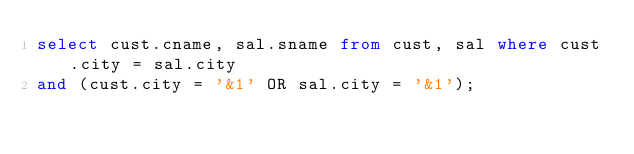<code> <loc_0><loc_0><loc_500><loc_500><_SQL_>select cust.cname, sal.sname from cust, sal where cust.city = sal.city
and (cust.city = '&1' OR sal.city = '&1');</code> 